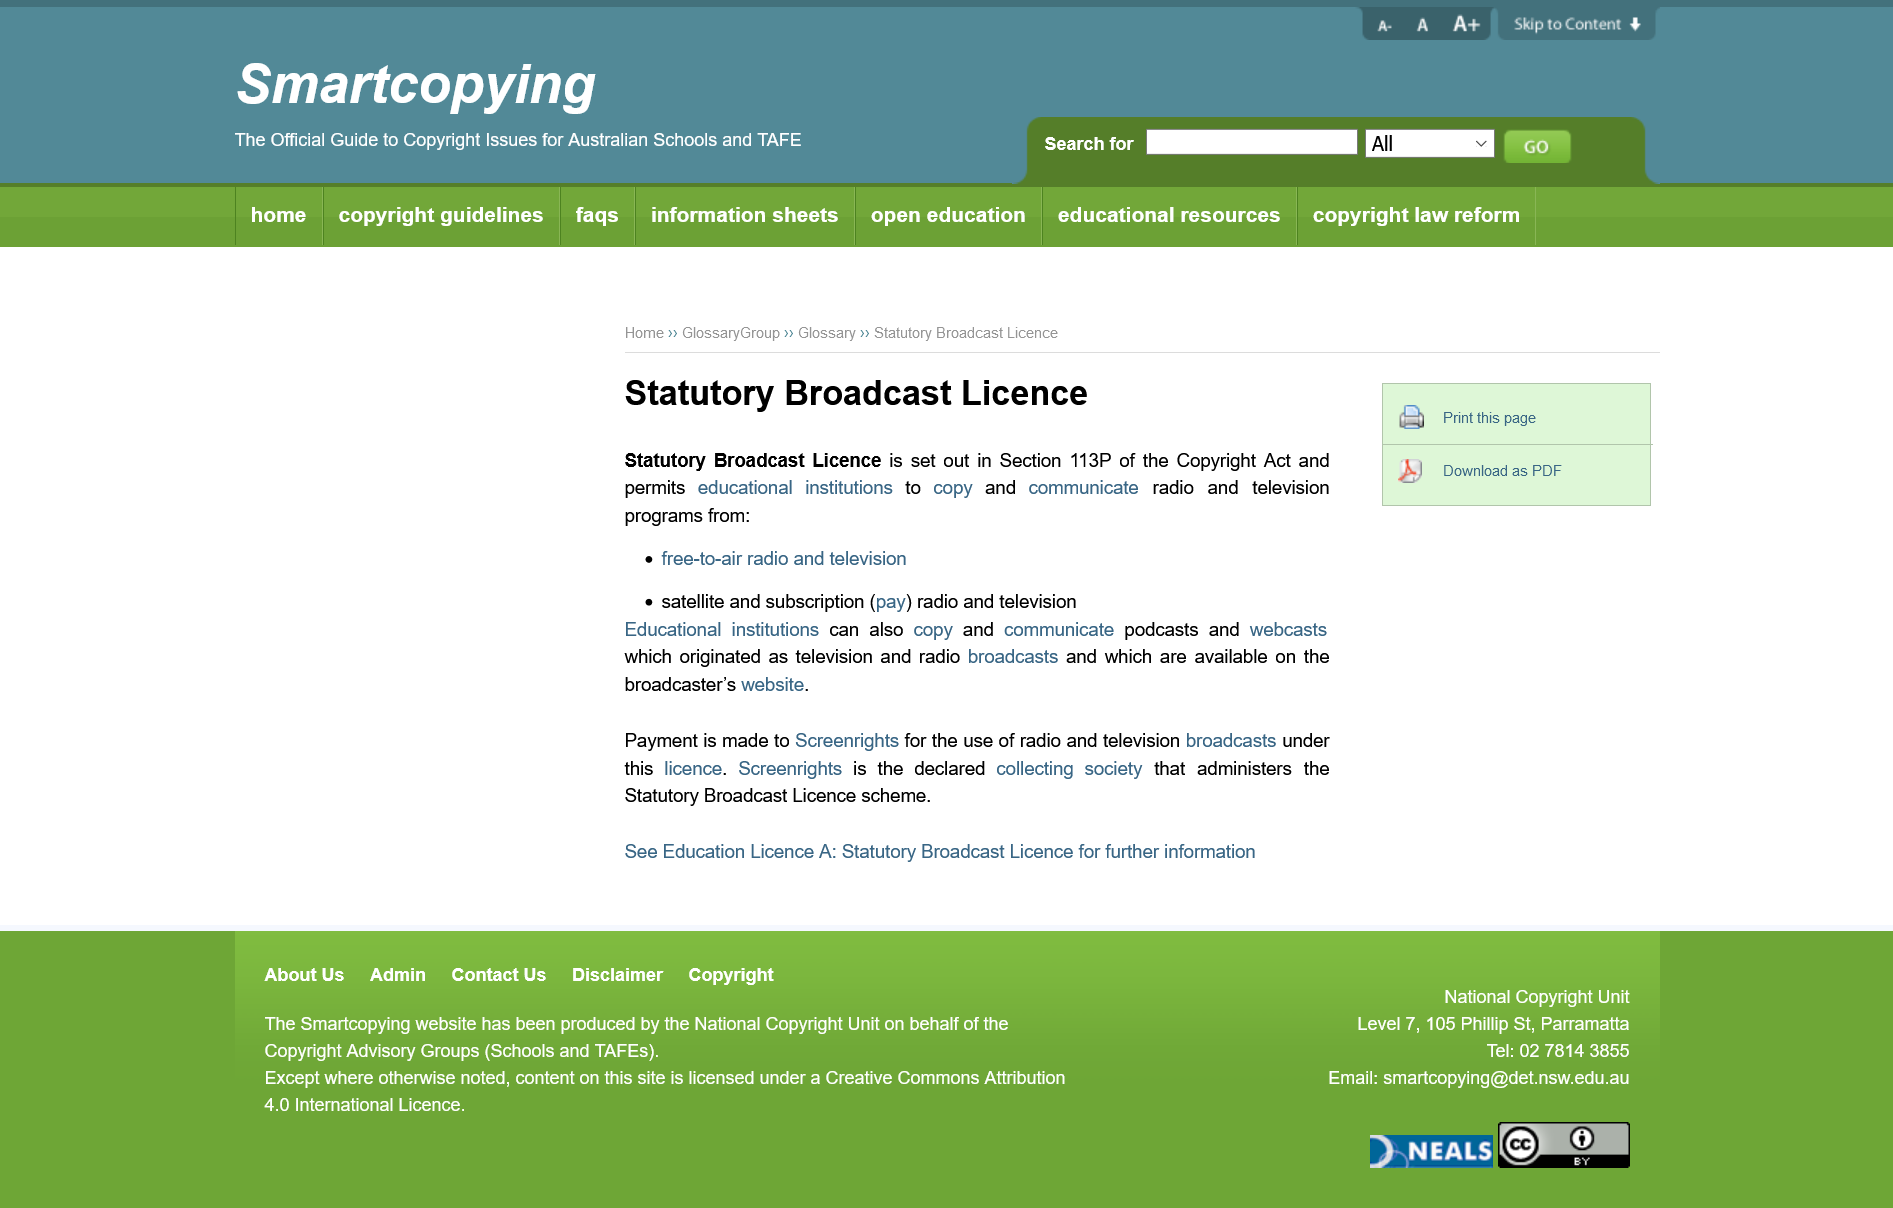Indicate a few pertinent items in this graphic. The Statutory Broadcast Licence provides educational institutions with the permission to copy and communicate radio and television programs from both free-to-air and satellite/subscription (pay) sources. Educational institutions can copy and communicate podcasts and webcasts, in addition to radio and television, as alternative media forms for effective communication and learning. Screenrights is the society that administers the Statutory Broadcast Licence scheme, which is responsible for collecting and distributing royalties to copyright holders for the use of their works in television and radio broadcasts. 